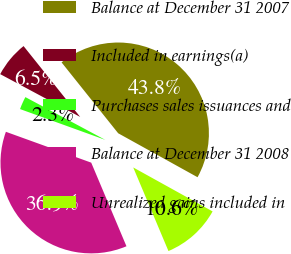Convert chart to OTSL. <chart><loc_0><loc_0><loc_500><loc_500><pie_chart><fcel>Balance at December 31 2007<fcel>Included in earnings(a)<fcel>Purchases sales issuances and<fcel>Balance at December 31 2008<fcel>Unrealized gains included in<nl><fcel>43.78%<fcel>6.45%<fcel>2.3%<fcel>36.87%<fcel>10.6%<nl></chart> 